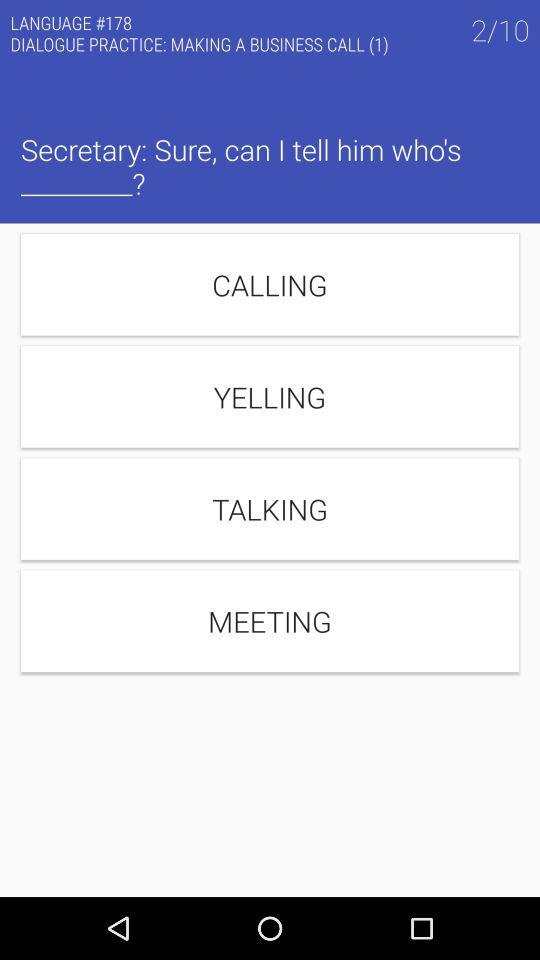Which question are we discussing? You are discussing the second question. 